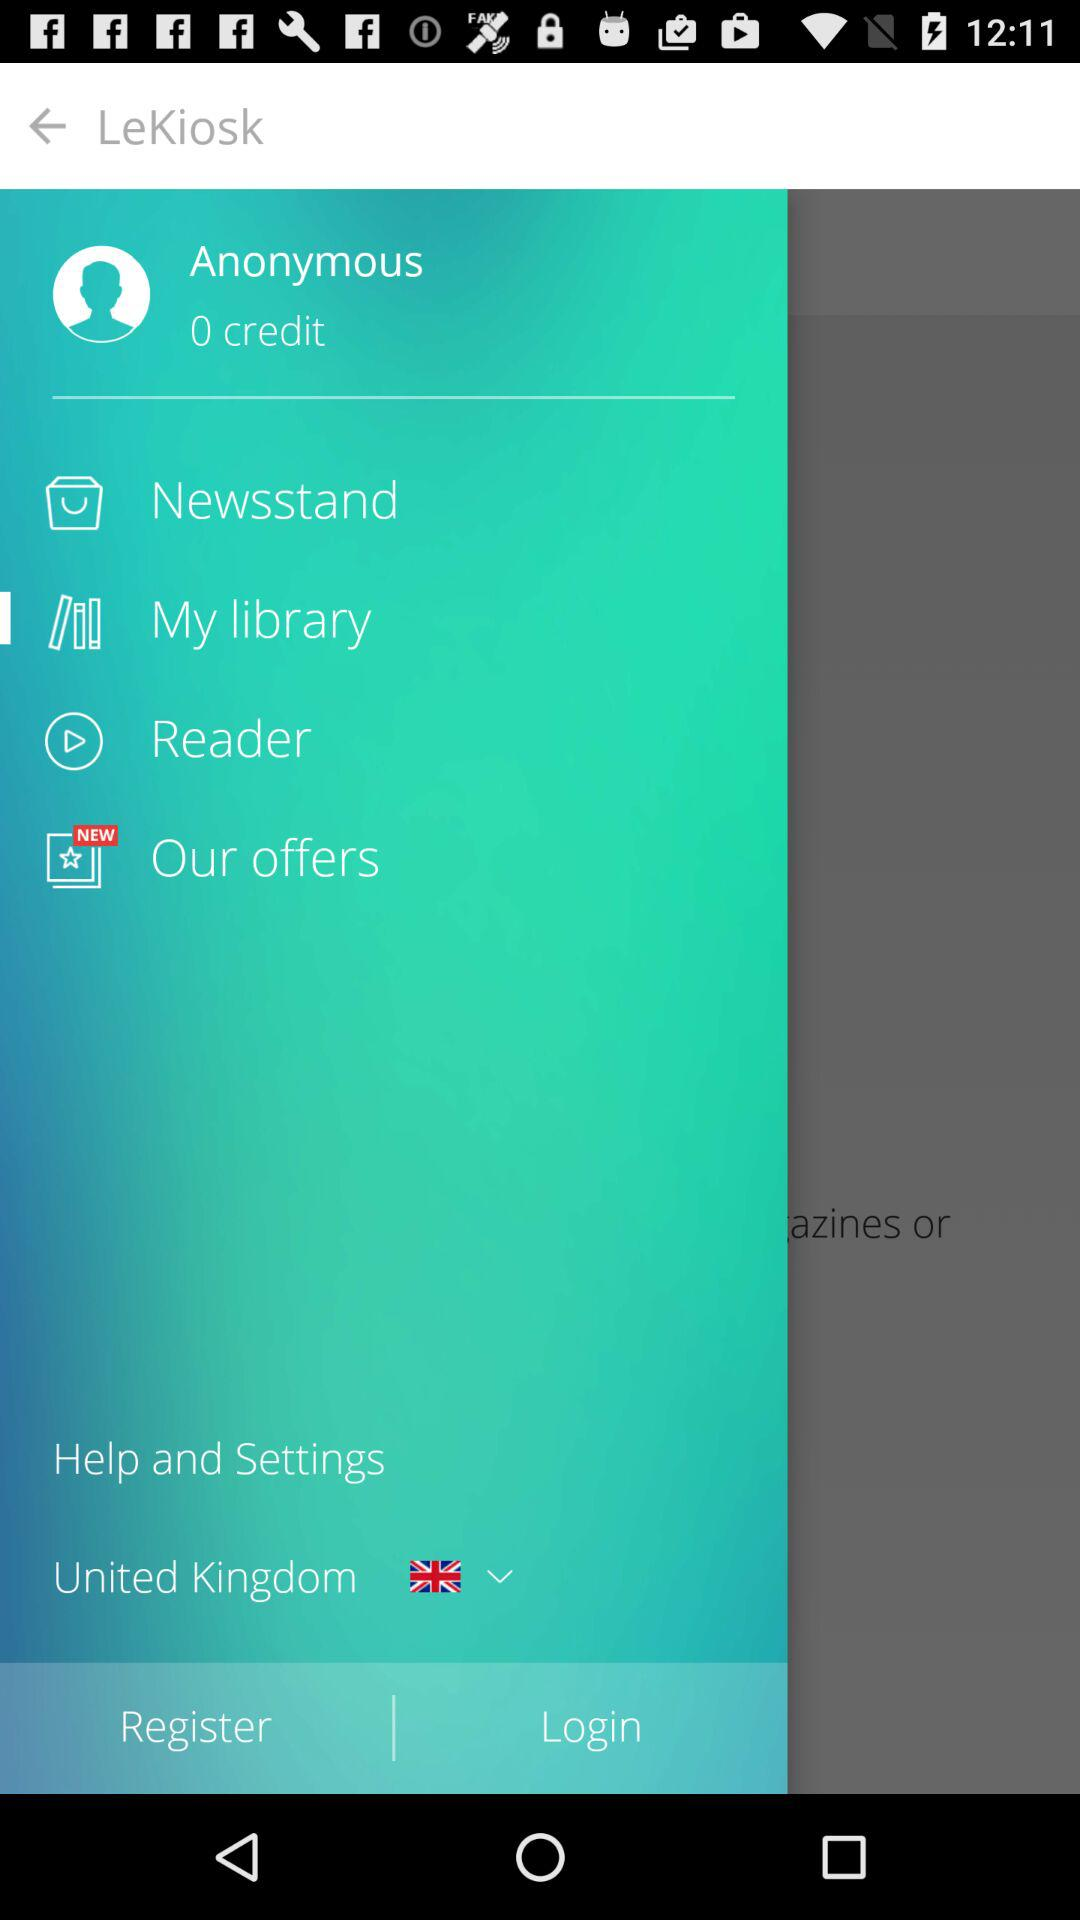What is the username? The username is "Anonymous". 